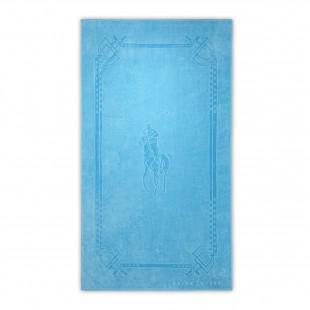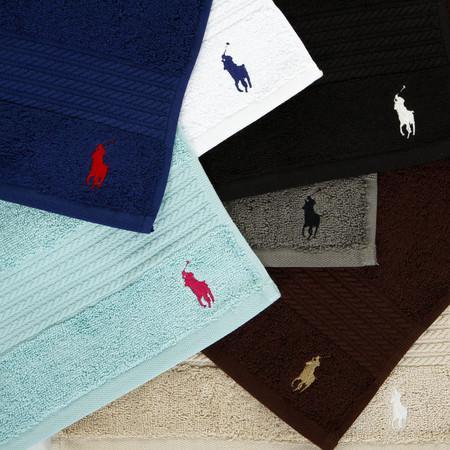The first image is the image on the left, the second image is the image on the right. Analyze the images presented: Is the assertion "In one of the images there is no towel with a logo of a different color than the towel." valid? Answer yes or no. Yes. The first image is the image on the left, the second image is the image on the right. Evaluate the accuracy of this statement regarding the images: "The right image contains only white towels, while the left image has at least one blue towel.". Is it true? Answer yes or no. No. 